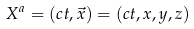<formula> <loc_0><loc_0><loc_500><loc_500>X ^ { a } = \left ( c t , { \vec { x } } \right ) = ( c t , x , y , z )</formula> 